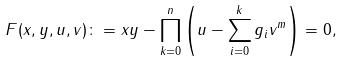<formula> <loc_0><loc_0><loc_500><loc_500>F ( x , y , u , v ) \colon = x y - \prod _ { k = 0 } ^ { n } \left ( u - \sum _ { i = 0 } ^ { k } g _ { i } v ^ { m } \right ) = 0 ,</formula> 